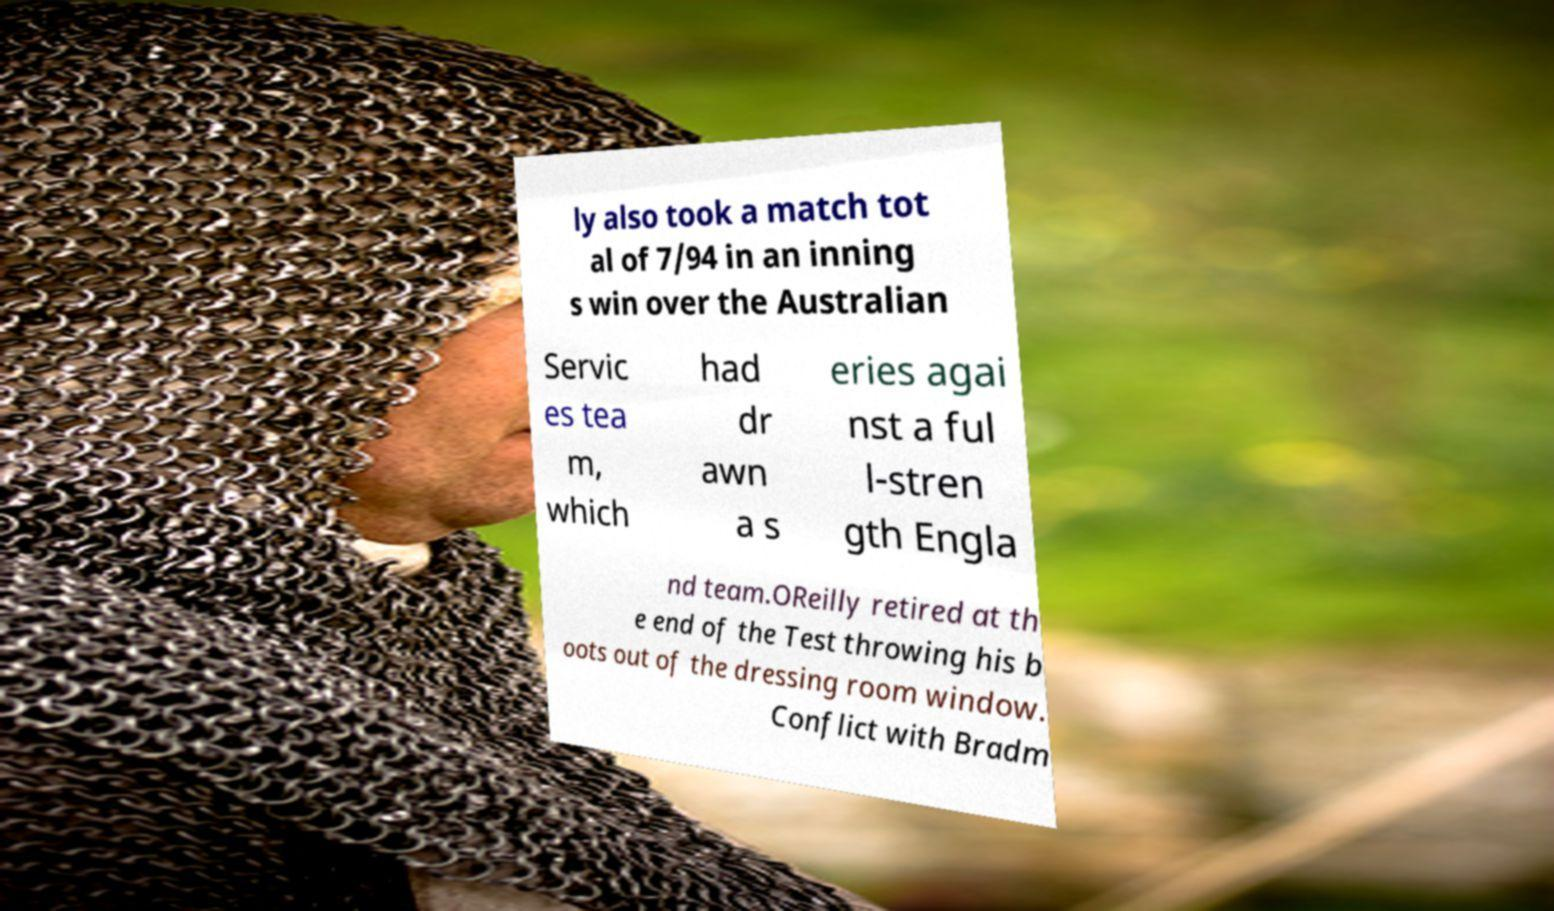There's text embedded in this image that I need extracted. Can you transcribe it verbatim? ly also took a match tot al of 7/94 in an inning s win over the Australian Servic es tea m, which had dr awn a s eries agai nst a ful l-stren gth Engla nd team.OReilly retired at th e end of the Test throwing his b oots out of the dressing room window. Conflict with Bradm 